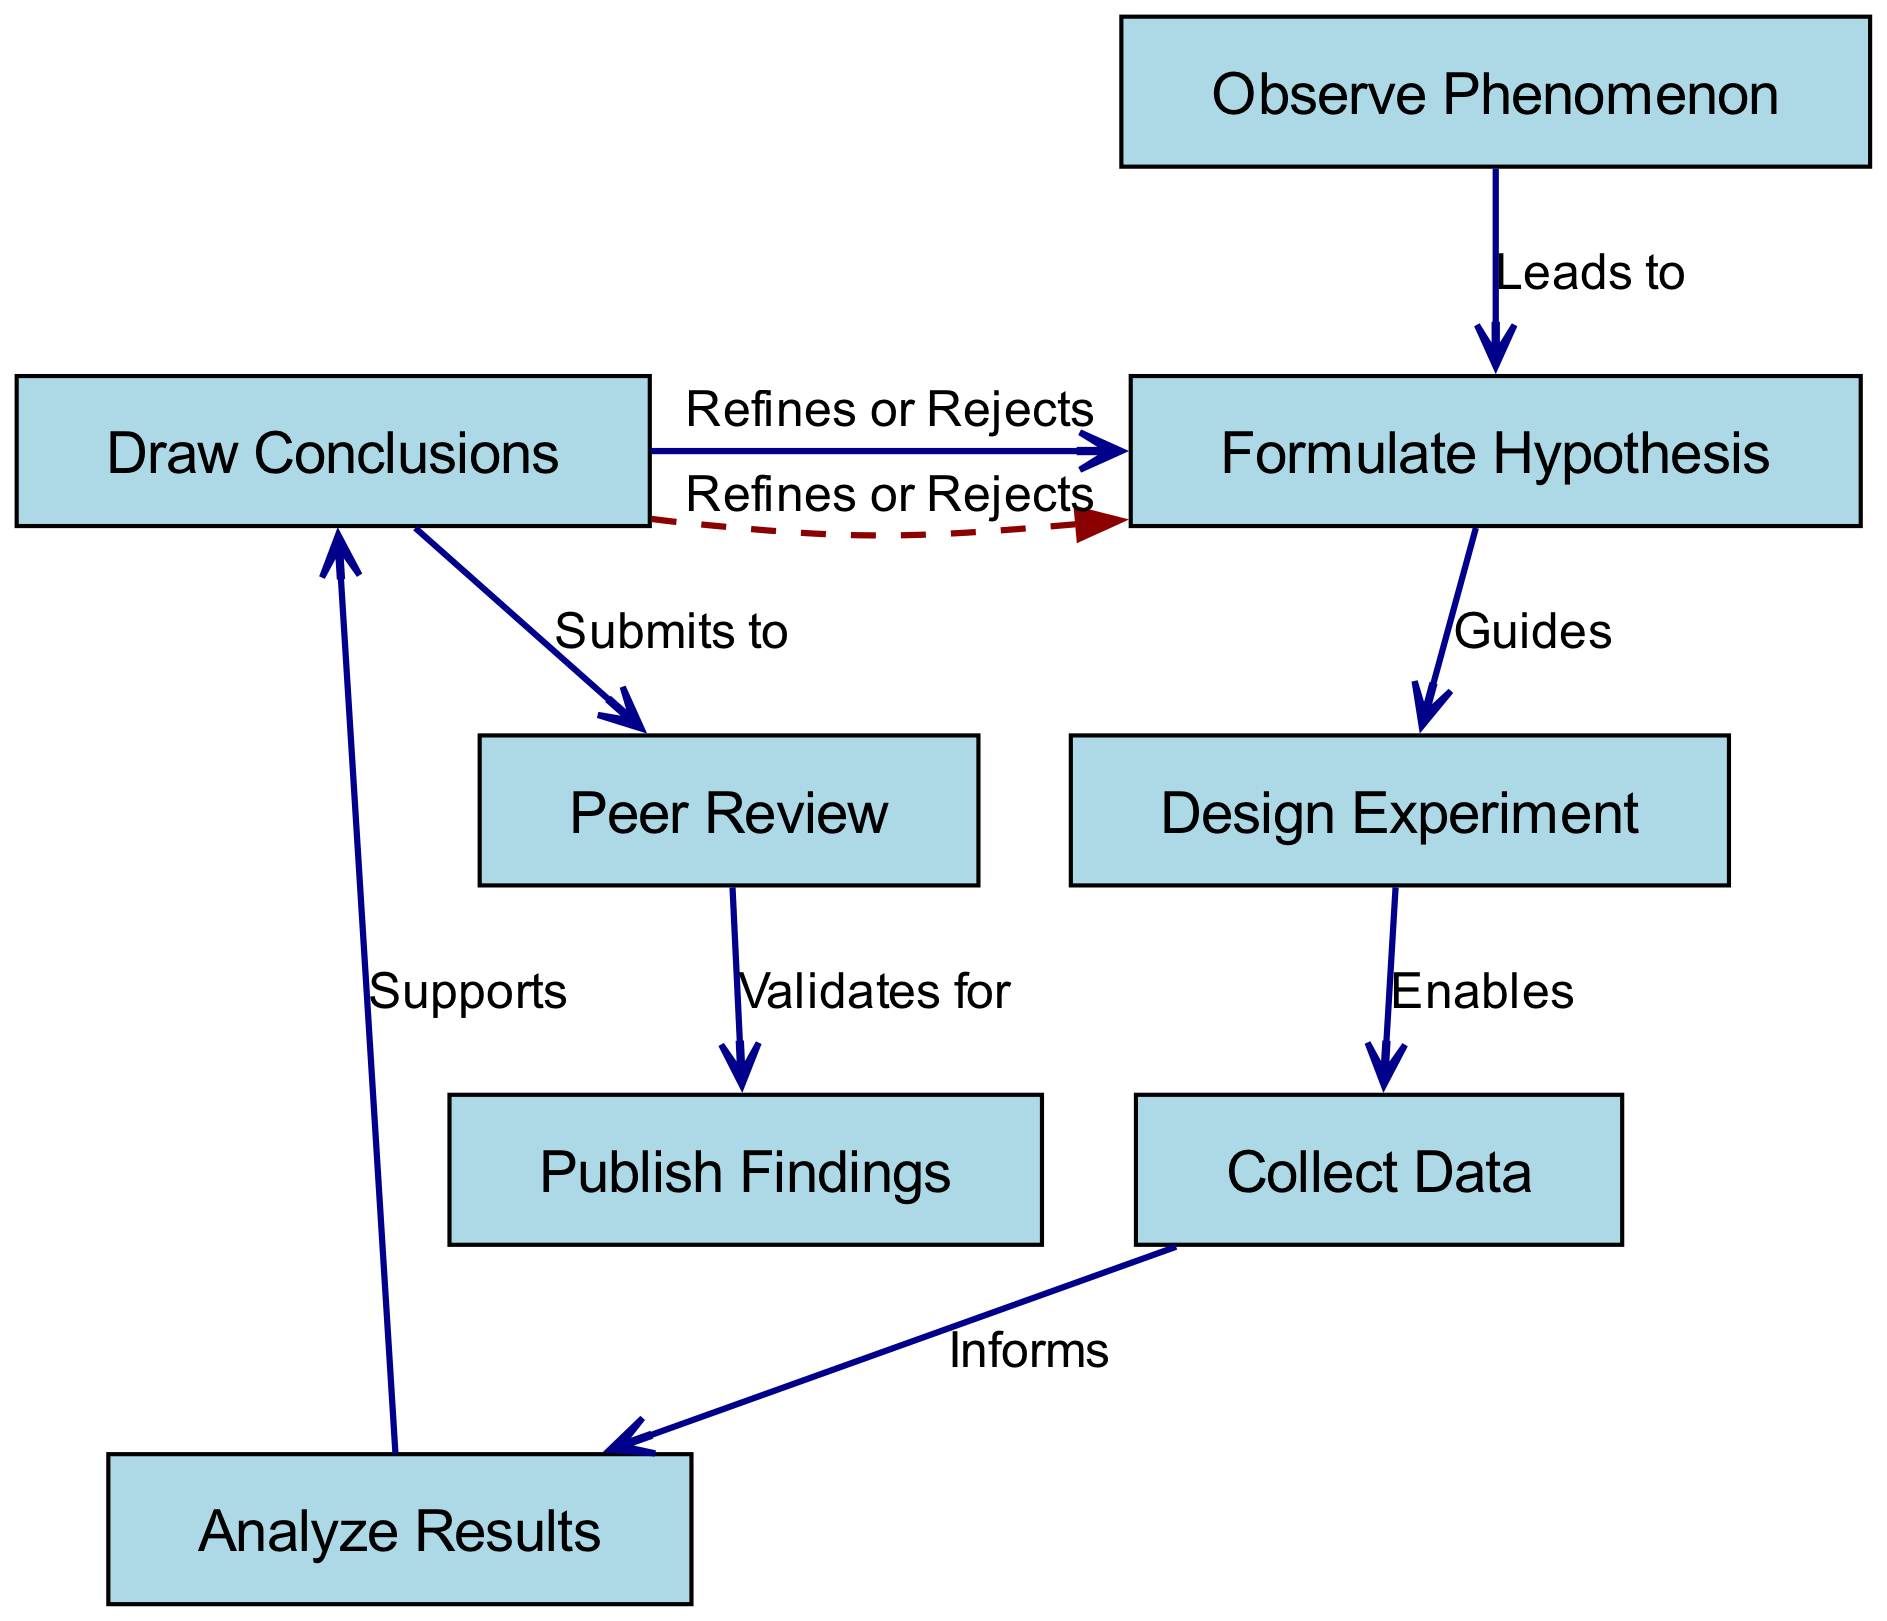What is the first step in the scientific method according to the diagram? The diagram starts with the node labeled "Observe Phenomenon," which is the initial step before any hypotheses or experiments are formed.
Answer: Observe Phenomenon How many nodes are present in the flowchart? By counting the listed activities in the diagram, there are a total of eight nodes, each representing a distinct step in the scientific process.
Answer: 8 What leads to the formulation of a hypothesis? The arrow labeled "Leads to" connects "Observe Phenomenon" to "Formulate Hypothesis," indicating that observation is what prompts the creation of a hypothesis.
Answer: Observe Phenomenon Which step directly informs the data collection? According to the edges shown in the diagram, "Design Experiment" connects directly to "Collect Data" with the label "Enables," indicating that the experimental design facilitates data collection.
Answer: Design Experiment What does peer review validate? The arrow from "Peer Review" to "Publish Findings" is labeled "Validates for," signifying that peer review serves to validate research findings prior to their publication.
Answer: Publish Findings What happens if the conclusions drawn reject the hypothesis? There is a feedback loop in the diagram that shows "Draw Conclusions" leading back to "Formulate Hypothesis," labeled "Refines or Rejects," indicating that conclusions can lead to refinement or rejection of the hypothesis.
Answer: Refines or Rejects What is the relationship between data analysis and conclusions? The edge labeled "Supports" connects "Analyze Results" to "Draw Conclusions," indicating that the analysis of results provides support for the conclusions drawn about the hypothesis.
Answer: Supports How many edges are displayed in the diagram? By examining the connections between nodes, we can see there are a total of seven edges connecting the various steps of the scientific method in the flowchart.
Answer: 7 